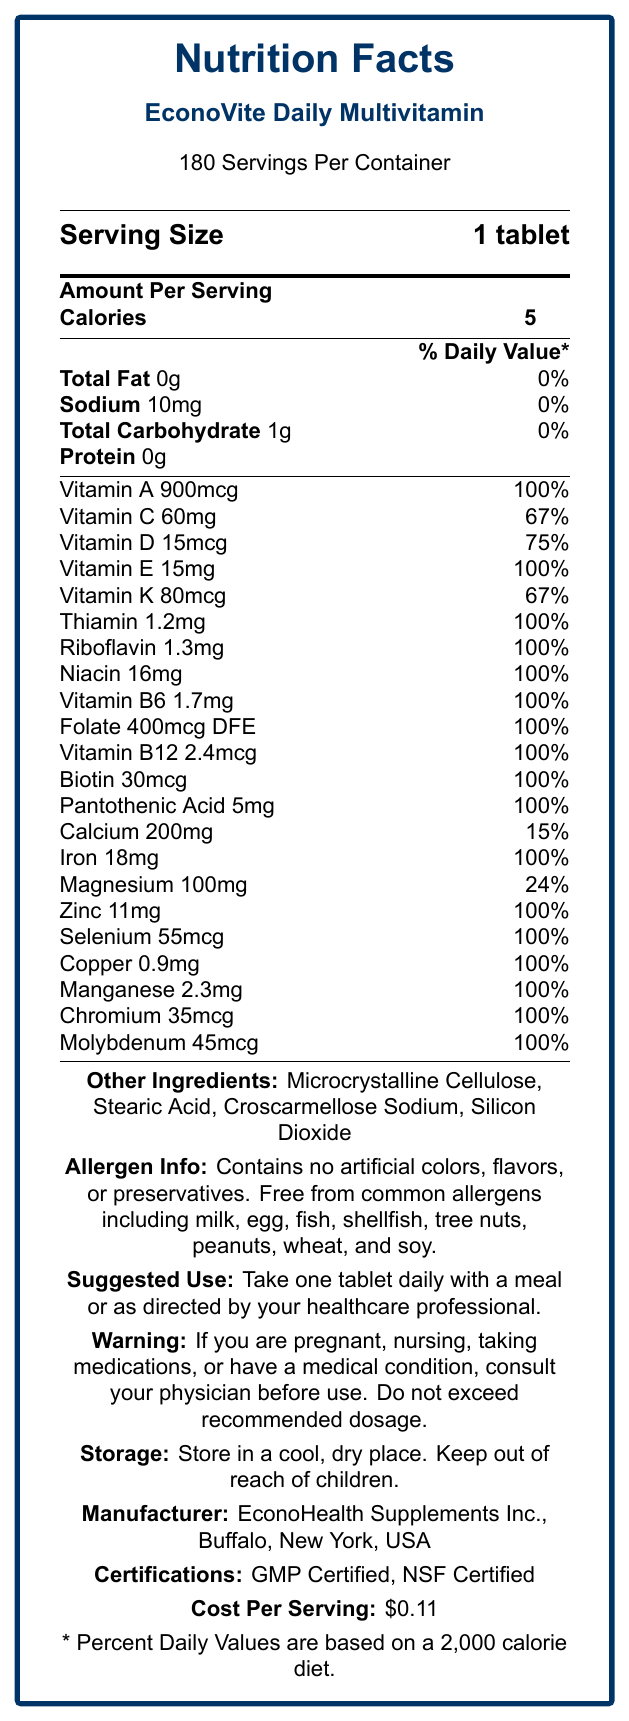what is the serving size of EconoVite Daily Multivitamin? The serving size is explicitly mentioned in the document as "Serving Size: 1 tablet".
Answer: 1 tablet how many servings are there per container? The document states "180 Servings Per Container".
Answer: 180 how many calories are in one serving of EconoVite Daily Multivitamin? The amount per serving shows "Calories: 5".
Answer: 5 what is the cost per serving of EconoVite Daily Multivitamin? The document mentions "Cost Per Serving: $0.11".
Answer: $0.11 what is the expiration period for EconoVite Daily Multivitamin? The document states the expiration period is "24 months from date of manufacture".
Answer: 24 months from date of manufacture which of the following vitamins has the highest daily value percentage in EconoVite Daily Multivitamin? A. Vitamin C B. Vitamin A C. Vitamin K D. Vitamin D Vitamin A has a daily value of 100%, which is higher compared to Vitamin C (67%), Vitamin K (67%), and Vitamin D (75%).
Answer: B how much Iron is provided in one tablet of EconoVite Daily Multivitamin? The document lists Iron in the vitamins and minerals section with an amount of 18mg.
Answer: 18mg does EconoVite Daily Multivitamin contain artificial colors, flavors, or preservatives? (Yes/No) The allergen information section states, "Contains no artificial colors, flavors, or preservatives".
Answer: No in which city and state is EconoVite Daily Multivitamin manufactured? The manufacturer information indicates the location as "Buffalo, New York, USA".
Answer: Buffalo, New York, USA identify two certifications that EconoVite Daily Multivitamin holds. The document lists "GMP Certified" and "NSF Certified" under certifications.
Answer: GMP Certified, NSF Certified which mineral in EconoVite Daily Multivitamin has the smallest daily value percentage? A. Calcium B. Iron C. Magnesium D. Zinc Calcium has a daily value of 15%, which is smaller than Iron (100%), Magnesium (24%), and Zinc (100%).
Answer: A how should EconoVite Daily Multivitamin be stored? The storage instructions clearly indicate this information.
Answer: Store in a cool, dry place. Keep out of reach of children. if a person follows a 2,500-calorie diet, what would be the daily value percentages for the vitamins and minerals listed? The document states, "* Percent Daily Values are based on a 2,000-calorie diet." It does not provide daily values for a 2,500-calorie diet.
Answer: Not enough information summarize the nutritional content and key features of EconoVite Daily Multivitamin. This summary captures the main features including servings per container, calorie content, vitamins and minerals, allergen information, manufacturing details, certifications, and cost per serving.
Answer: EconoVite Daily Multivitamin is an economical supplement with a serving size of 1 tablet and 180 servings per container. Each serving contains 5 calories, various essential vitamins and minerals mostly at 100% daily value, no artificial additives, and free from common allergens. It is manufactured by EconoHealth Supplements Inc. in Buffalo, NY, is GMP and NSF certified, and costs $0.11 per serving. if I am pregnant, should I take EconoVite Daily Multivitamin without consultation? The warning section advises consulting a physician if pregnant, nursing, taking medication, or having a medical condition before use.
Answer: No 